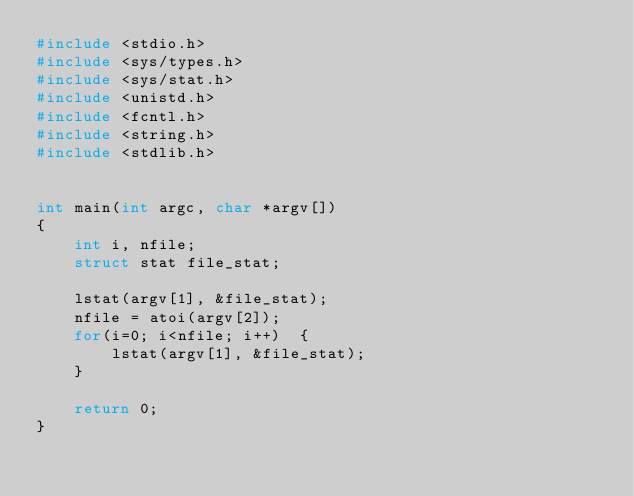Convert code to text. <code><loc_0><loc_0><loc_500><loc_500><_C_>#include <stdio.h>
#include <sys/types.h>
#include <sys/stat.h>
#include <unistd.h>
#include <fcntl.h>
#include <string.h>
#include <stdlib.h>


int main(int argc, char *argv[])
{
	int i, nfile;
	struct stat file_stat;

	lstat(argv[1], &file_stat);
	nfile = atoi(argv[2]);
	for(i=0; i<nfile; i++)	{
		lstat(argv[1], &file_stat);
	}

	return 0;
}


</code> 